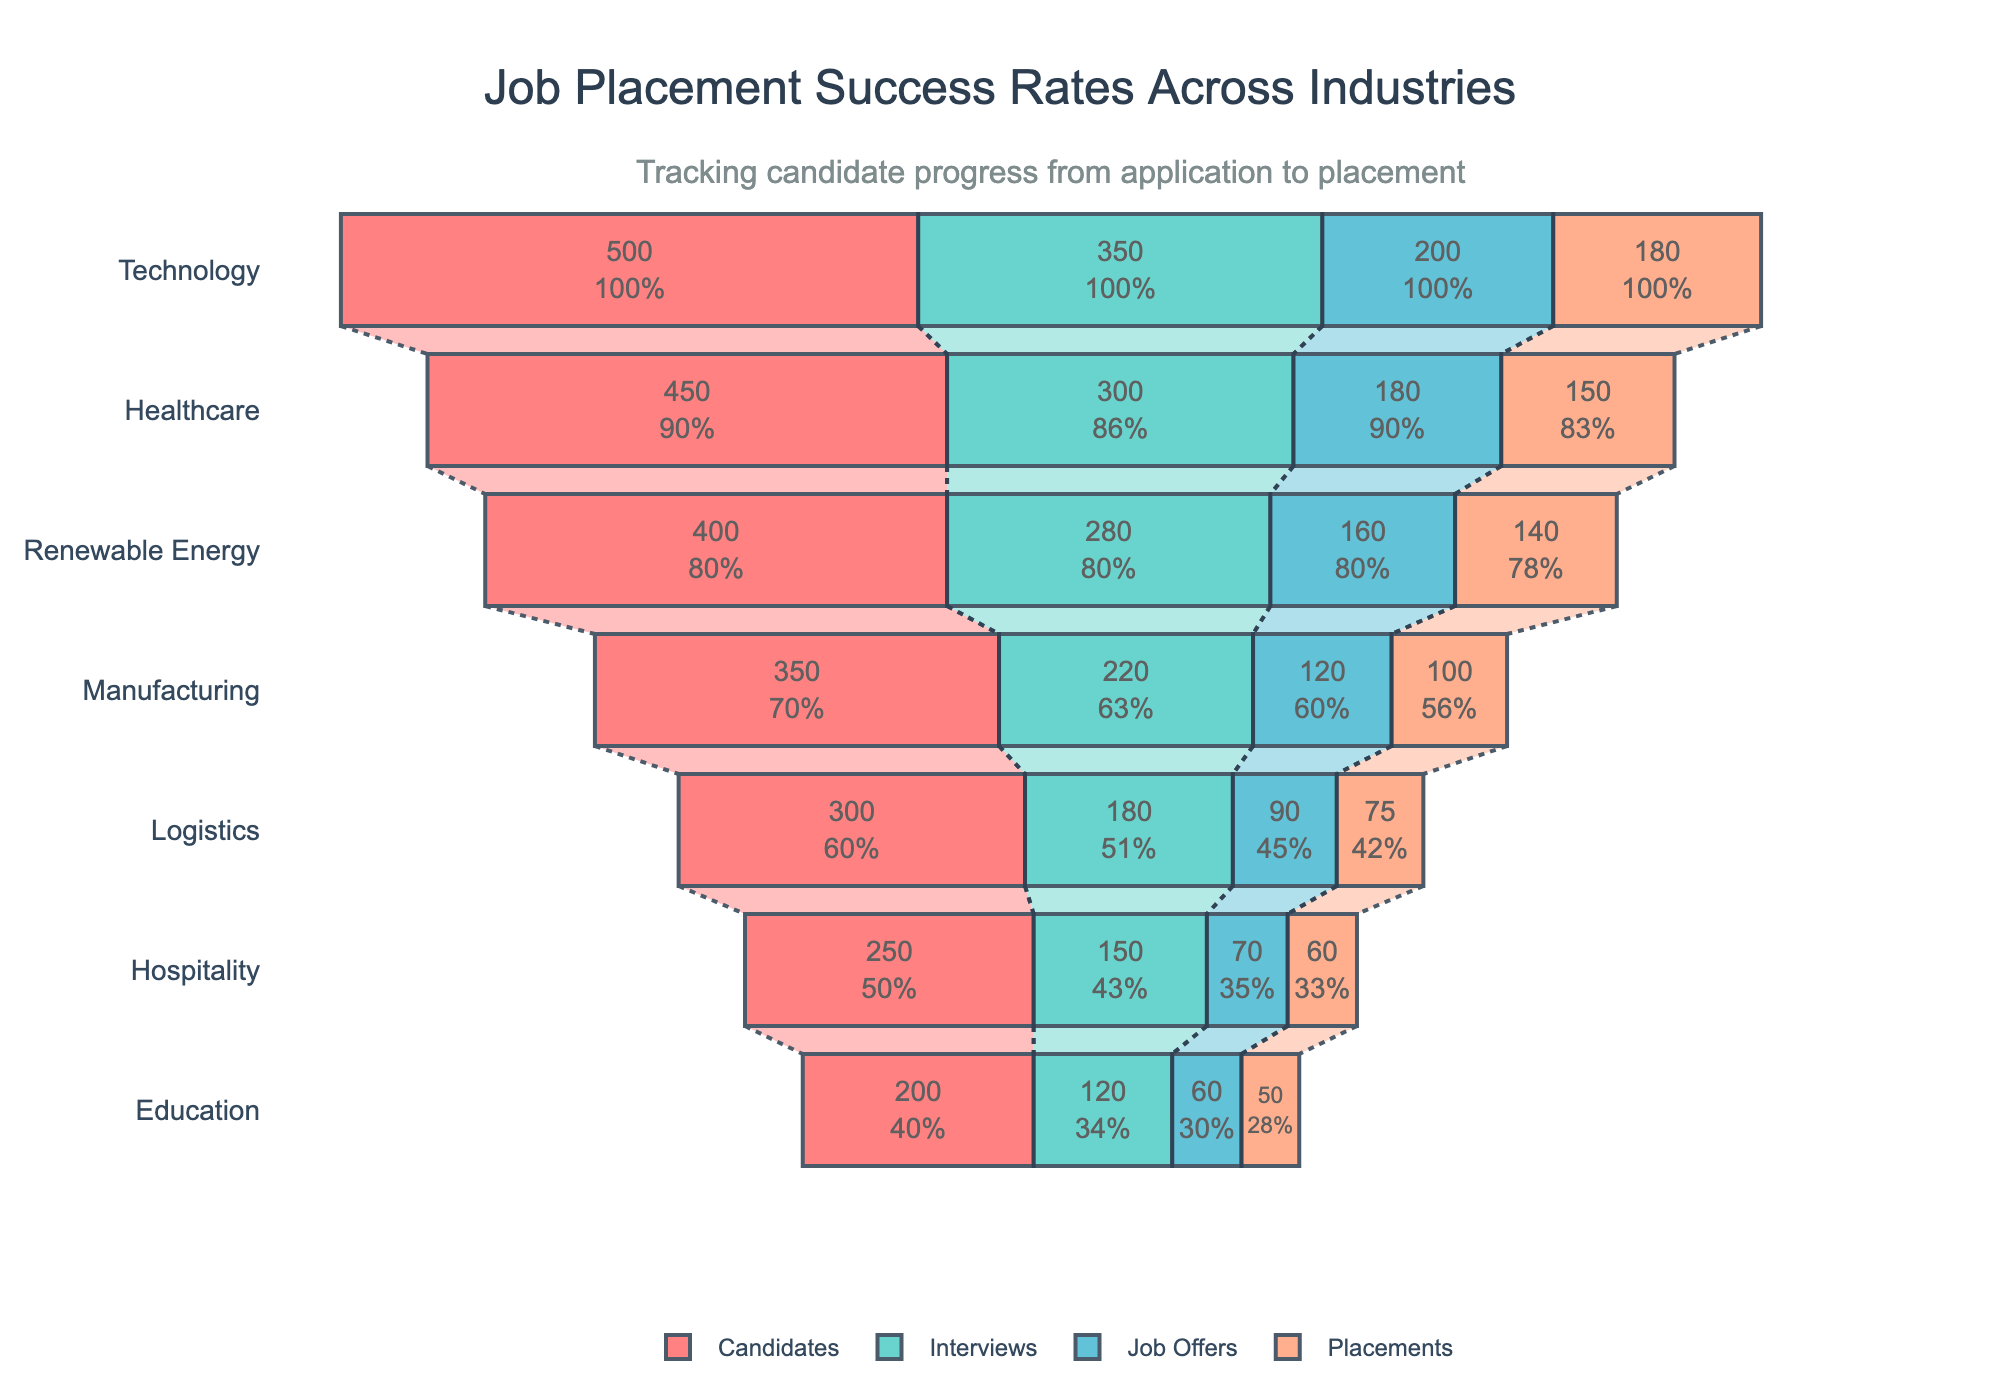What is the title of the funnel chart? The title is usually displayed at the top of the chart. In this case, the title mentions job placement success rates across industries.
Answer: "Job Placement Success Rates Across Industries" Which industry has the highest number of candidates? Look for the longest bar in the "Candidates" category. The bar for "Technology" is the longest.
Answer: Technology How many stages are there in the funnel chart? The stages are the individual segments for each industry. Here, we have "Candidates," "Interviews," "Job Offers," and "Placements."
Answer: 4 Which industry shows the highest percentage of candidates getting placements? Compare the final placement percentage of candidates across all industries. The highest percentage can be determined from the bar sizes or text info in the "Placements" stage.
Answer: Technology How many more job offers did Healthcare have compared to Logistics? Subtract the number of job offers in Logistics from those in Healthcare. Healthcare has 180 offers, while Logistics has 90. So, 180 - 90 = 90.
Answer: 90 Which industry had the fewest job offers? Look for the shortest bar in the "Job Offers" stage. The "Hospitality" bar is the shortest for this stage.
Answer: Hospitality Between which two consecutive stages does Manufacturing see the largest drop-off in numbers? Compare the differences in values between consecutive stages for Manufacturing. The biggest drop is between "Candidates" (350) and "Interviews" (220), a difference of 130.
Answer: Candidates to Interviews How many total candidates were there across all industries? Add the number of candidates for all industries together: 500 + 450 + 400 + 350 + 300 + 250 + 200 = 2450.
Answer: 2450 Which industry has the smallest gap between job offers and placements? Look at the difference between the "Job Offers" and "Placements" stages for each industry. "Education" has the smallest difference (60 - 50 = 10).
Answer: Education What percentage of the Renewable Energy candidates received job offers? Use the values for Renewable Energy: 160 out of 400 candidates received job offers. So, (160/400) * 100 = 40%.
Answer: 40% 